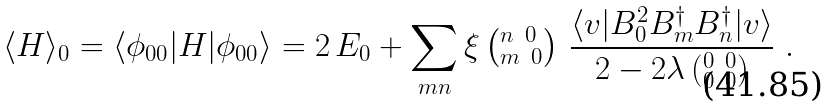<formula> <loc_0><loc_0><loc_500><loc_500>\langle H \rangle _ { 0 } = \langle \phi _ { 0 0 } | H | \phi _ { 0 0 } \rangle = 2 \, E _ { 0 } + \sum _ { m n } \xi \left ( ^ { n \ 0 } _ { m \ 0 } \right ) \, \frac { \langle v | B _ { 0 } ^ { 2 } B _ { m } ^ { \dag } B _ { n } ^ { \dag } | v \rangle } { 2 - 2 \lambda \left ( ^ { 0 \ 0 } _ { 0 \ 0 } \right ) } \ .</formula> 